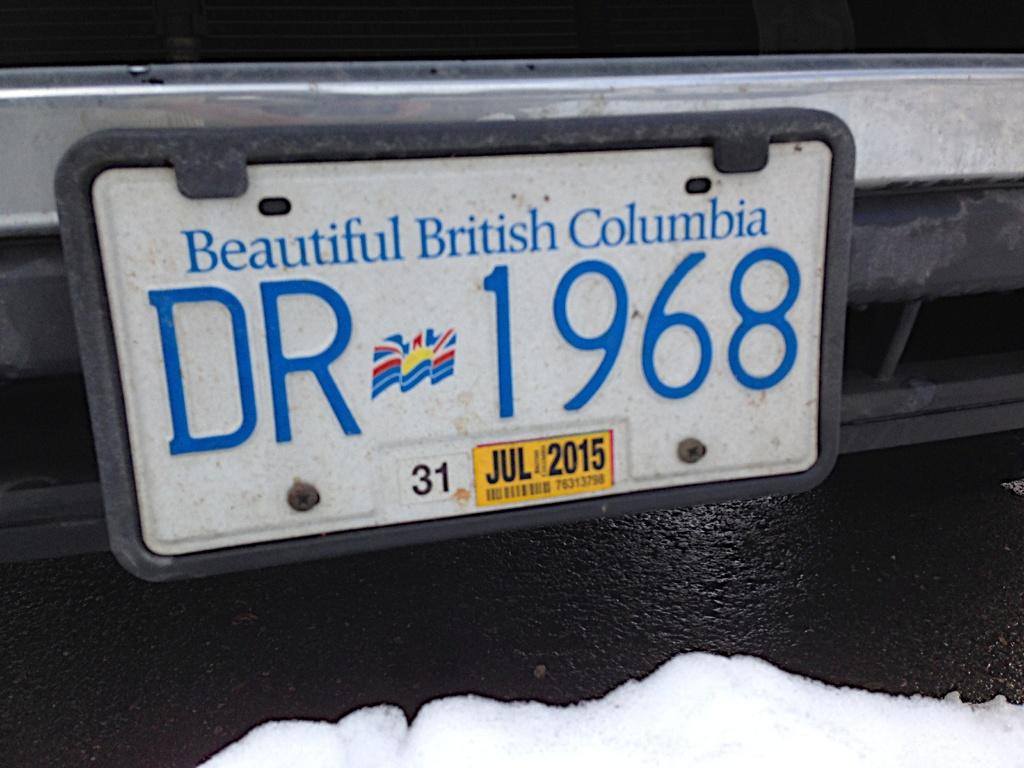What state is the license plate from ?
Your answer should be compact. British columbia. When does it expire?
Make the answer very short. Jul 2015. 